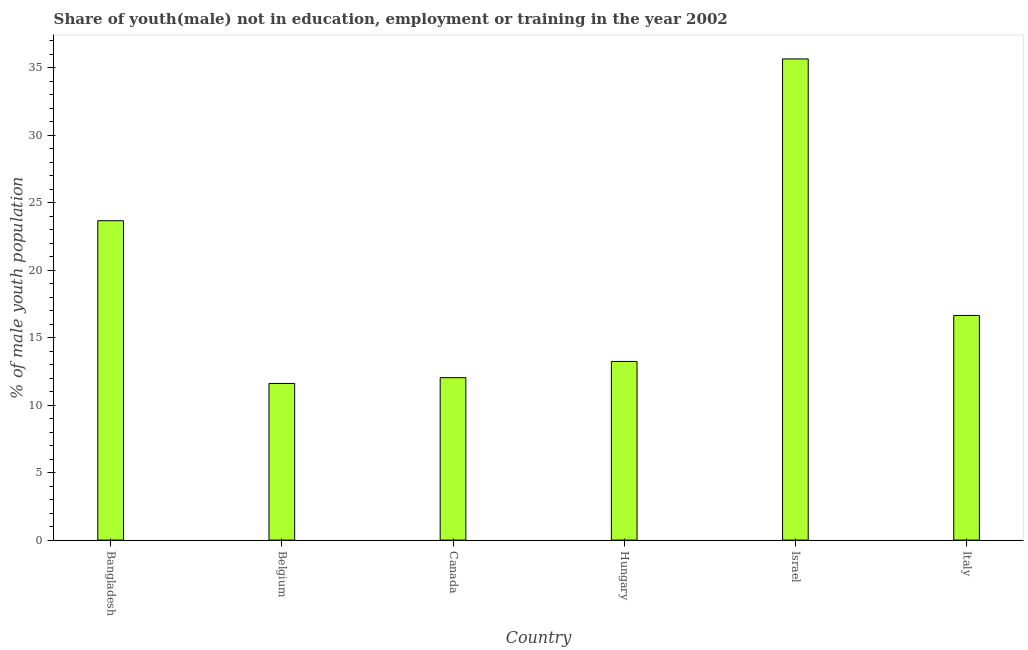What is the title of the graph?
Your answer should be very brief. Share of youth(male) not in education, employment or training in the year 2002. What is the label or title of the X-axis?
Your answer should be very brief. Country. What is the label or title of the Y-axis?
Your response must be concise. % of male youth population. What is the unemployed male youth population in Canada?
Provide a succinct answer. 12.04. Across all countries, what is the maximum unemployed male youth population?
Your response must be concise. 35.66. Across all countries, what is the minimum unemployed male youth population?
Make the answer very short. 11.61. In which country was the unemployed male youth population maximum?
Provide a succinct answer. Israel. What is the sum of the unemployed male youth population?
Provide a succinct answer. 112.87. What is the difference between the unemployed male youth population in Bangladesh and Belgium?
Provide a succinct answer. 12.06. What is the average unemployed male youth population per country?
Your answer should be very brief. 18.81. What is the median unemployed male youth population?
Provide a short and direct response. 14.94. In how many countries, is the unemployed male youth population greater than 15 %?
Provide a short and direct response. 3. What is the ratio of the unemployed male youth population in Belgium to that in Italy?
Keep it short and to the point. 0.7. Is the unemployed male youth population in Canada less than that in Italy?
Ensure brevity in your answer.  Yes. What is the difference between the highest and the second highest unemployed male youth population?
Your response must be concise. 11.99. What is the difference between the highest and the lowest unemployed male youth population?
Keep it short and to the point. 24.05. What is the difference between two consecutive major ticks on the Y-axis?
Offer a very short reply. 5. What is the % of male youth population in Bangladesh?
Keep it short and to the point. 23.67. What is the % of male youth population of Belgium?
Provide a short and direct response. 11.61. What is the % of male youth population of Canada?
Ensure brevity in your answer.  12.04. What is the % of male youth population of Hungary?
Your answer should be very brief. 13.24. What is the % of male youth population of Israel?
Offer a terse response. 35.66. What is the % of male youth population of Italy?
Your response must be concise. 16.65. What is the difference between the % of male youth population in Bangladesh and Belgium?
Your answer should be compact. 12.06. What is the difference between the % of male youth population in Bangladesh and Canada?
Your response must be concise. 11.63. What is the difference between the % of male youth population in Bangladesh and Hungary?
Your answer should be very brief. 10.43. What is the difference between the % of male youth population in Bangladesh and Israel?
Your answer should be very brief. -11.99. What is the difference between the % of male youth population in Bangladesh and Italy?
Offer a very short reply. 7.02. What is the difference between the % of male youth population in Belgium and Canada?
Keep it short and to the point. -0.43. What is the difference between the % of male youth population in Belgium and Hungary?
Your response must be concise. -1.63. What is the difference between the % of male youth population in Belgium and Israel?
Make the answer very short. -24.05. What is the difference between the % of male youth population in Belgium and Italy?
Your answer should be compact. -5.04. What is the difference between the % of male youth population in Canada and Israel?
Your answer should be very brief. -23.62. What is the difference between the % of male youth population in Canada and Italy?
Provide a succinct answer. -4.61. What is the difference between the % of male youth population in Hungary and Israel?
Give a very brief answer. -22.42. What is the difference between the % of male youth population in Hungary and Italy?
Your answer should be compact. -3.41. What is the difference between the % of male youth population in Israel and Italy?
Your response must be concise. 19.01. What is the ratio of the % of male youth population in Bangladesh to that in Belgium?
Make the answer very short. 2.04. What is the ratio of the % of male youth population in Bangladesh to that in Canada?
Ensure brevity in your answer.  1.97. What is the ratio of the % of male youth population in Bangladesh to that in Hungary?
Offer a very short reply. 1.79. What is the ratio of the % of male youth population in Bangladesh to that in Israel?
Make the answer very short. 0.66. What is the ratio of the % of male youth population in Bangladesh to that in Italy?
Provide a succinct answer. 1.42. What is the ratio of the % of male youth population in Belgium to that in Hungary?
Ensure brevity in your answer.  0.88. What is the ratio of the % of male youth population in Belgium to that in Israel?
Give a very brief answer. 0.33. What is the ratio of the % of male youth population in Belgium to that in Italy?
Give a very brief answer. 0.7. What is the ratio of the % of male youth population in Canada to that in Hungary?
Your response must be concise. 0.91. What is the ratio of the % of male youth population in Canada to that in Israel?
Provide a succinct answer. 0.34. What is the ratio of the % of male youth population in Canada to that in Italy?
Your answer should be compact. 0.72. What is the ratio of the % of male youth population in Hungary to that in Israel?
Offer a very short reply. 0.37. What is the ratio of the % of male youth population in Hungary to that in Italy?
Offer a very short reply. 0.8. What is the ratio of the % of male youth population in Israel to that in Italy?
Your response must be concise. 2.14. 